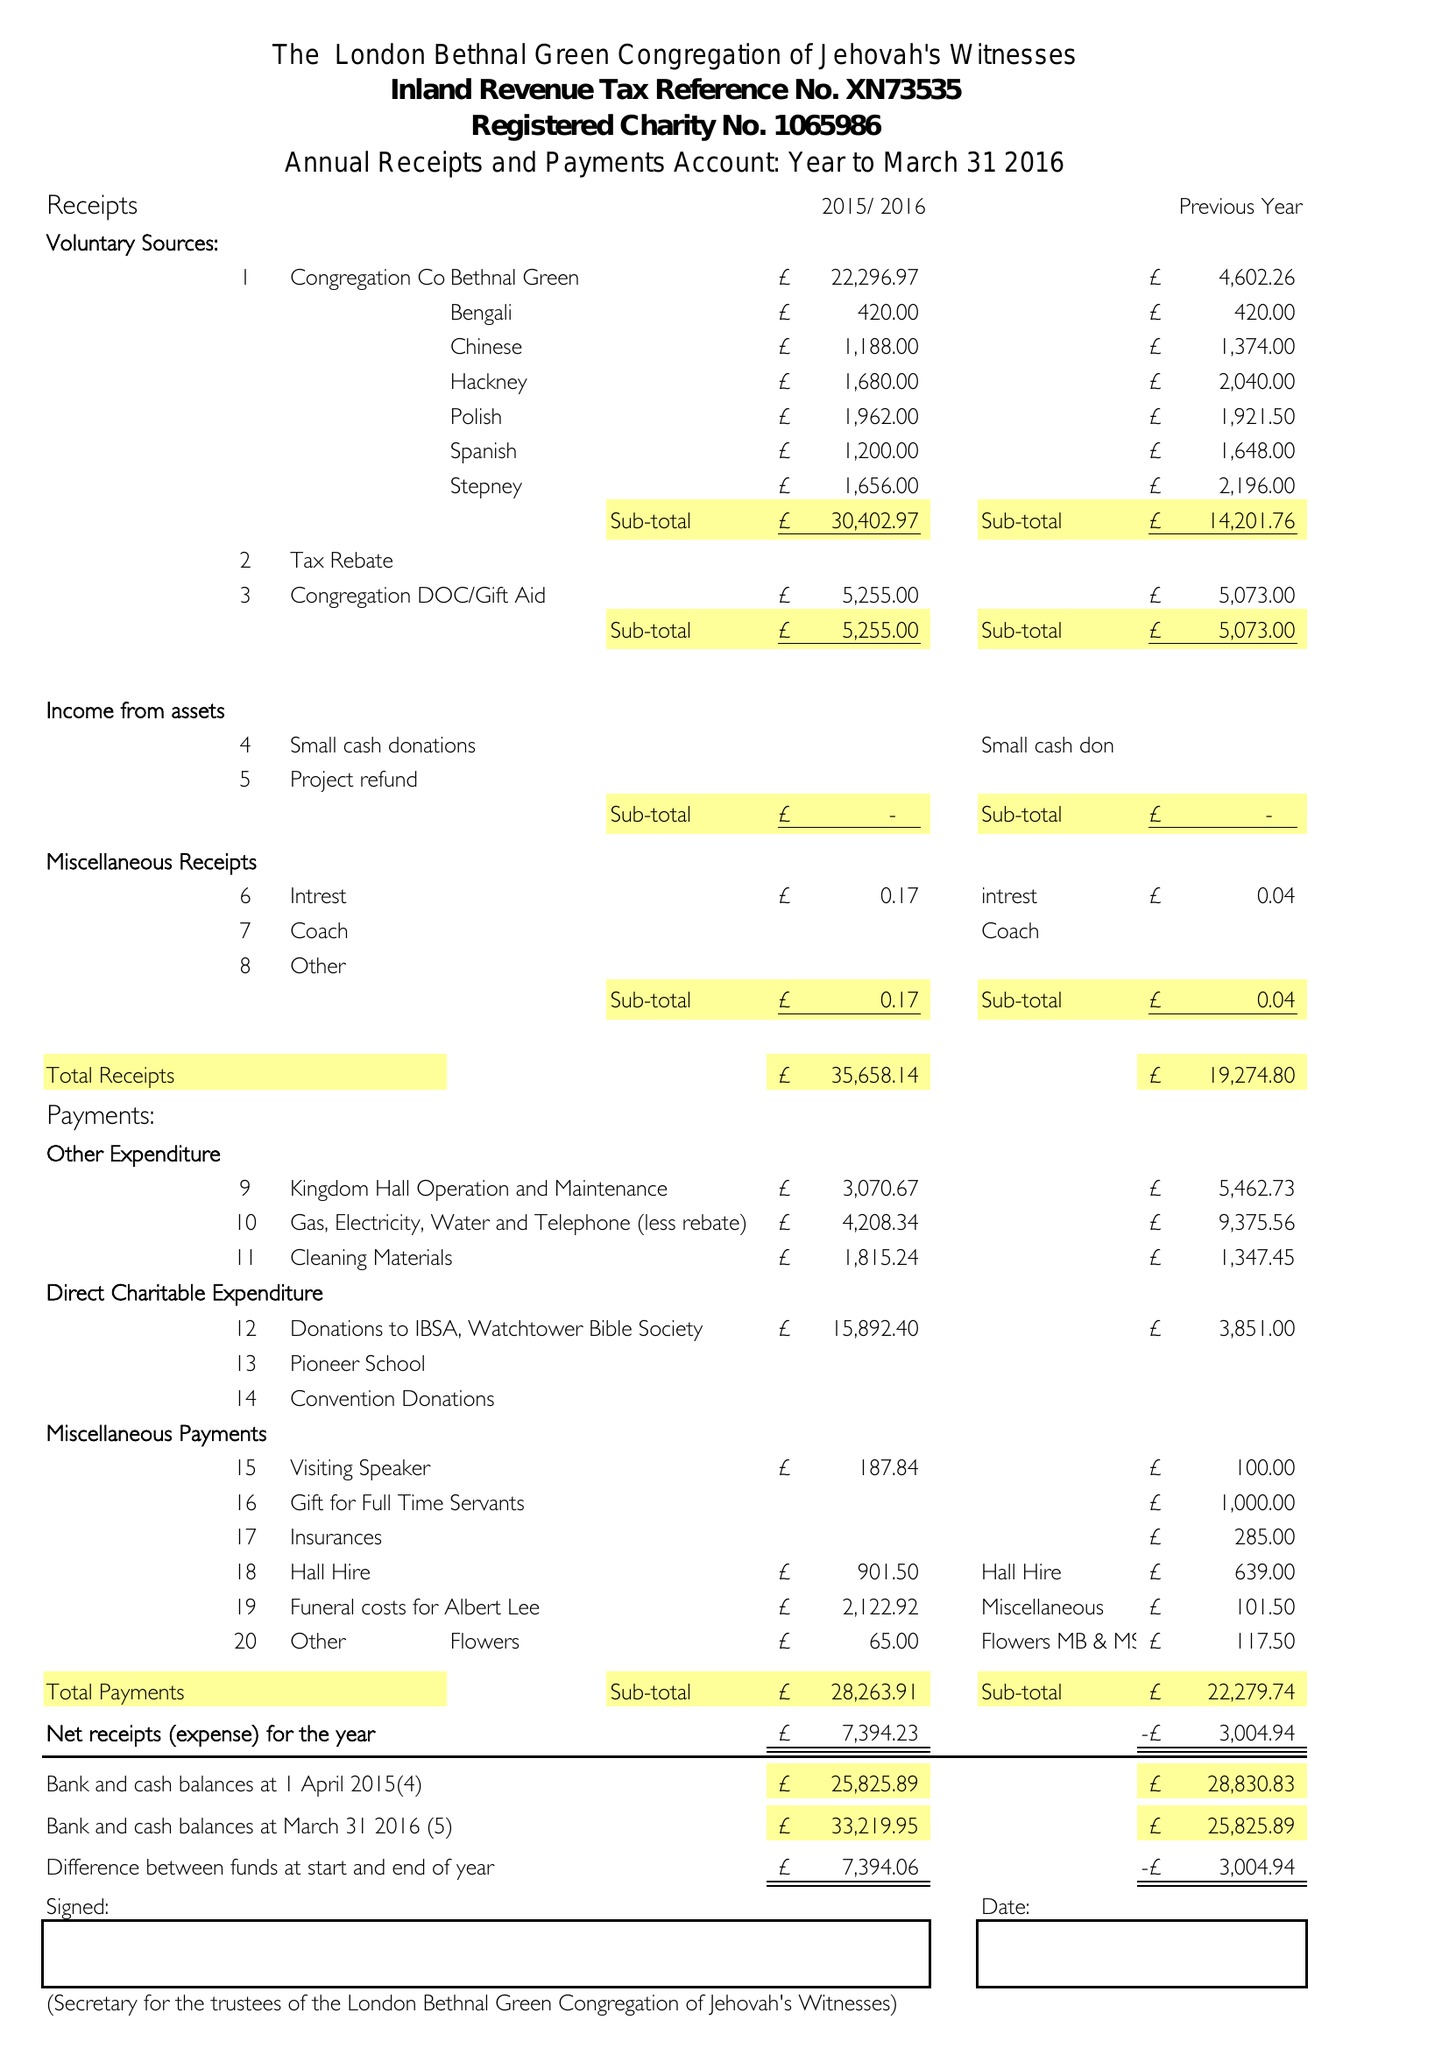What is the value for the charity_number?
Answer the question using a single word or phrase. 1065986 